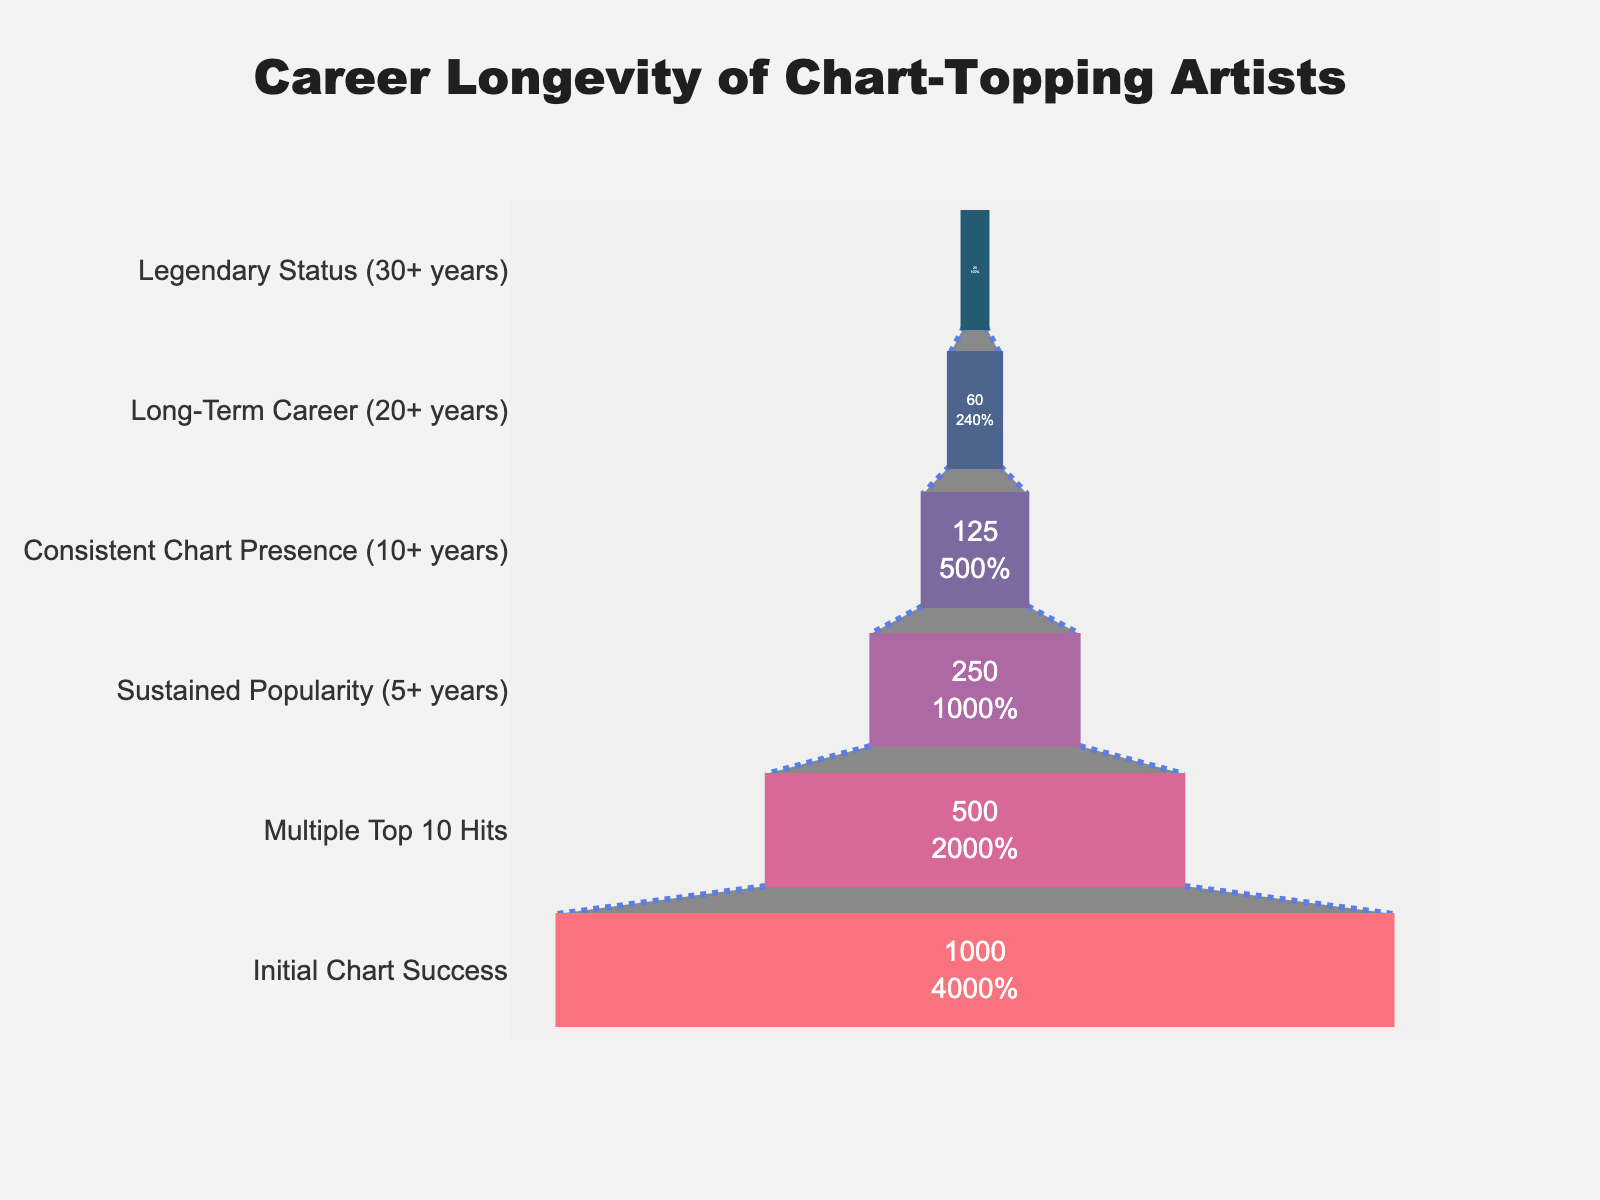what's the title of the chart? The title is displayed at the top center of the chart. It is typically used to describe the main topic or purpose of the figure.
Answer: Career Longevity of Chart-Topping Artists How many stages are shown in the funnel chart? Count the number of distinct stages listed on the left side of the funnel chart.
Answer: 6 What percentage of artists achieve a long-term career (20+ years) relative to those with initial chart success? Identify the number of artists in the 'Long-Term Career (20+ years)' stage and divide by the number in the 'Initial Chart Success' stage, then multiply by 100 to convert to a percentage.
Answer: 6% Which color is used for the 'Legendary Status (30+ years)' stage? Observe the color assigned to the 'Legendary Status (30+ years)' stage, which is at the bottom of the funnel chart.
Answer: Red (#f95d6a) How many artists have sustained popularity for 5+ years? Locate the 'Sustained Popularity (5+ years)' stage and note the number displayed inside the funnel section.
Answer: 250 What is the difference in the number of artists between the 'Initial Chart Success' stage and the 'Consistent Chart Presence (10+ years)' stage? Subtract the number of artists in the 'Consistent Chart Presence (10+ years)' stage from the number in the 'Initial Chart Success' stage.
Answer: 875 Which stage has the steepest decline in the number of artists? Compare the number of artists between consecutive stages and identify the largest difference.
Answer: Initial Chart Success to Multiple Top 10 Hits How many artists achieve 'Multiple Top 10 Hits' but do not sustain popularity for 5+ years? Subtract the number of artists in the 'Sustained Popularity (5+ years)' stage from the number in the 'Multiple Top 10 Hits' stage.
Answer: 250 Is the number of artists achieving 'Legendary Status (30+ years)' greater than half of those achieving 'Consistent Chart Presence (10+ years)'? Calculate half of the number of artists in the 'Consistent Chart Presence (10+ years)' stage and compare it to the number in the 'Legendary Status (30+ years)' stage.
Answer: No What percentage of artists with multiple top 10 hits achieve consistent chart presence for 10+ years? Divide the number of artists in the 'Consistent Chart Presence (10+ years)' stage by the number in the 'Multiple Top 10 Hits' stage, then multiply by 100.
Answer: 25% 